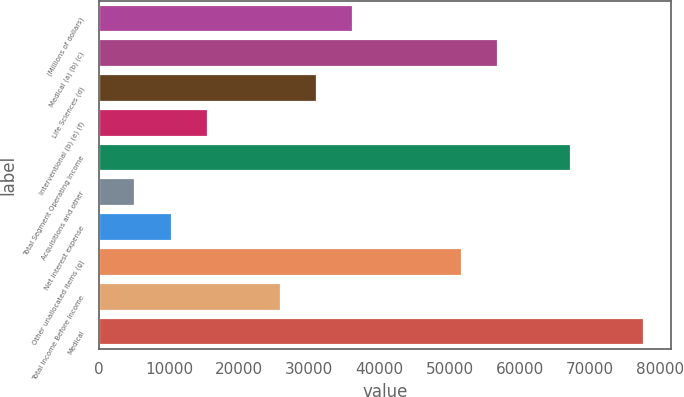Convert chart to OTSL. <chart><loc_0><loc_0><loc_500><loc_500><bar_chart><fcel>(Millions of dollars)<fcel>Medical (a) (b) (c)<fcel>Life Sciences (d)<fcel>Interventional (b) (e) (f)<fcel>Total Segment Operating Income<fcel>Acquisitions and other<fcel>Net interest expense<fcel>Other unallocated items (g)<fcel>Total Income Before Income<fcel>Medical<nl><fcel>36244.5<fcel>56938.5<fcel>31071<fcel>15550.5<fcel>67285.5<fcel>5203.5<fcel>10377<fcel>51765<fcel>25897.5<fcel>77632.5<nl></chart> 